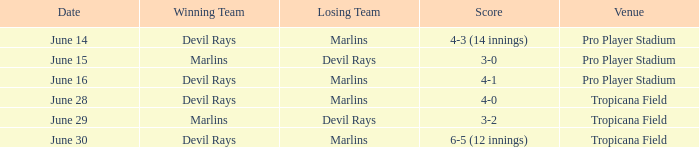Who won by a score of 4-1? Devil Rays. 